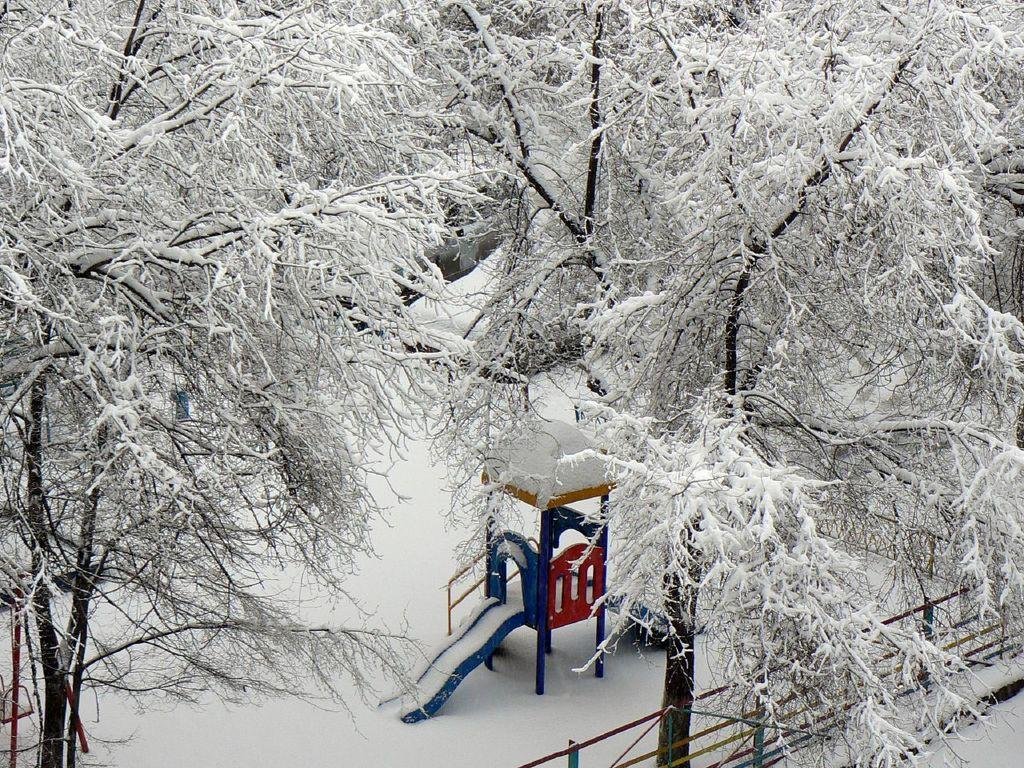What type of playground equipment is visible in the image? There is a swing and a slide in the image. Where are the swing and slide located? Both the swing and slide are on the surface of the snow. What can be seen in the background of the image? There are trees in the background of the image. How are the trees affected by the weather conditions? The trees are covered in snow. Can you see any grapes hanging from the trees in the image? There are no grapes visible in the image; the trees are covered in snow. How does the swing say good-bye to the slide in the image? The swing and slide are inanimate objects and do not have the ability to say good-bye. 